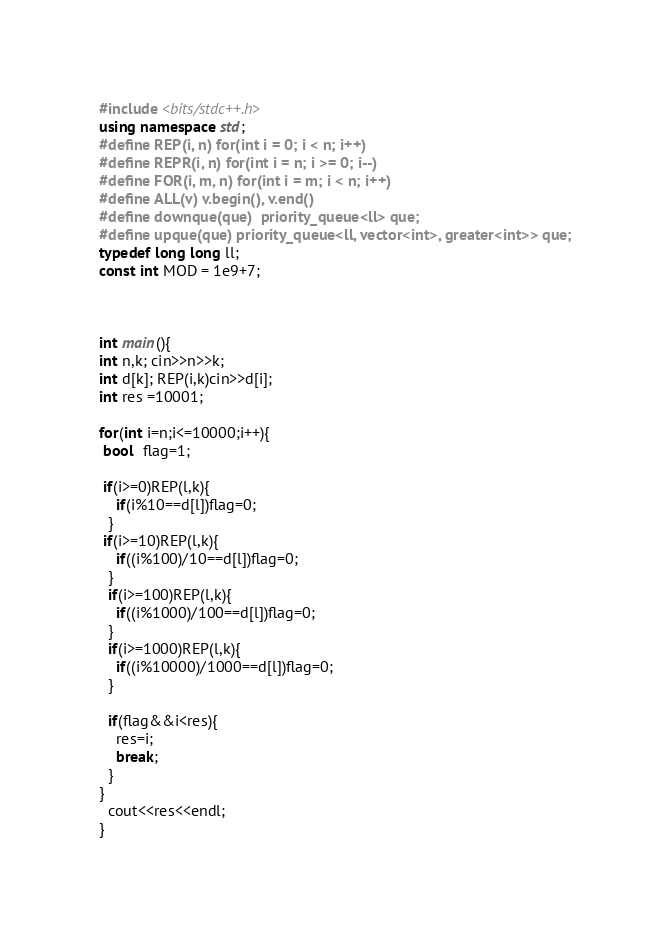<code> <loc_0><loc_0><loc_500><loc_500><_C++_>#include <bits/stdc++.h>
using namespace std;
#define REP(i, n) for(int i = 0; i < n; i++)
#define REPR(i, n) for(int i = n; i >= 0; i--)
#define FOR(i, m, n) for(int i = m; i < n; i++)
#define ALL(v) v.begin(), v.end()
#define downque(que)  priority_queue<ll> que;
#define upque(que) priority_queue<ll, vector<int>, greater<int>> que;
typedef long long ll;
const int MOD = 1e9+7;



int main(){
int n,k; cin>>n>>k;
int d[k]; REP(i,k)cin>>d[i];
int res =10001;

for(int i=n;i<=10000;i++){
 bool  flag=1;
 
 if(i>=0)REP(l,k){
    if(i%10==d[l])flag=0;
  }
 if(i>=10)REP(l,k){
    if((i%100)/10==d[l])flag=0;
  }
  if(i>=100)REP(l,k){
    if((i%1000)/100==d[l])flag=0;
  }
  if(i>=1000)REP(l,k){
    if((i%10000)/1000==d[l])flag=0;
  }

  if(flag&&i<res){
    res=i;
    break;
  }
}
  cout<<res<<endl;
}
</code> 